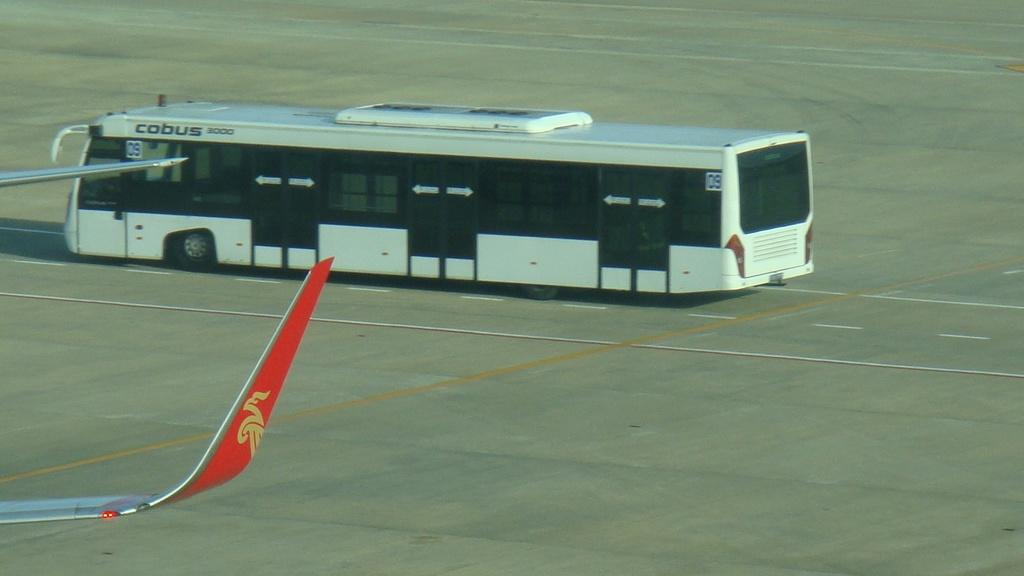What is the main subject in the center of the image? There is a bus in the center of the image. What can be seen on the left side of the image? There are aeroplane wings on the left side of the image. What is visible in the background of the image? There is a road visible in the background of the image. How many stories tall is the cobweb in the image? There is no cobweb present in the image. 